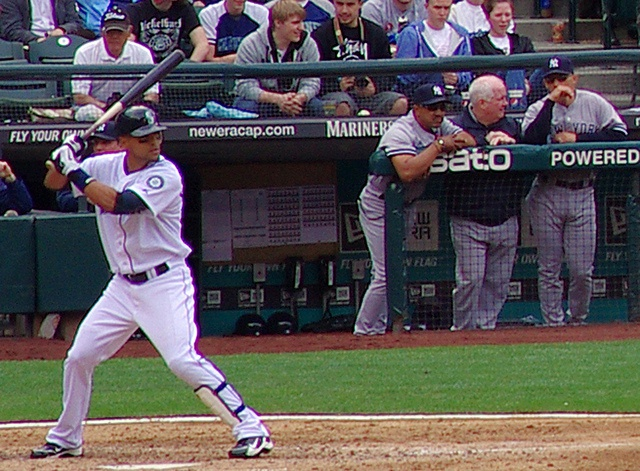Describe the objects in this image and their specific colors. I can see people in darkblue, lavender, darkgray, and gray tones, people in darkblue, black, gray, purple, and navy tones, people in darkblue, gray, darkgray, black, and maroon tones, people in darkblue, black, gray, and darkgray tones, and people in darkblue, black, gray, brown, and maroon tones in this image. 